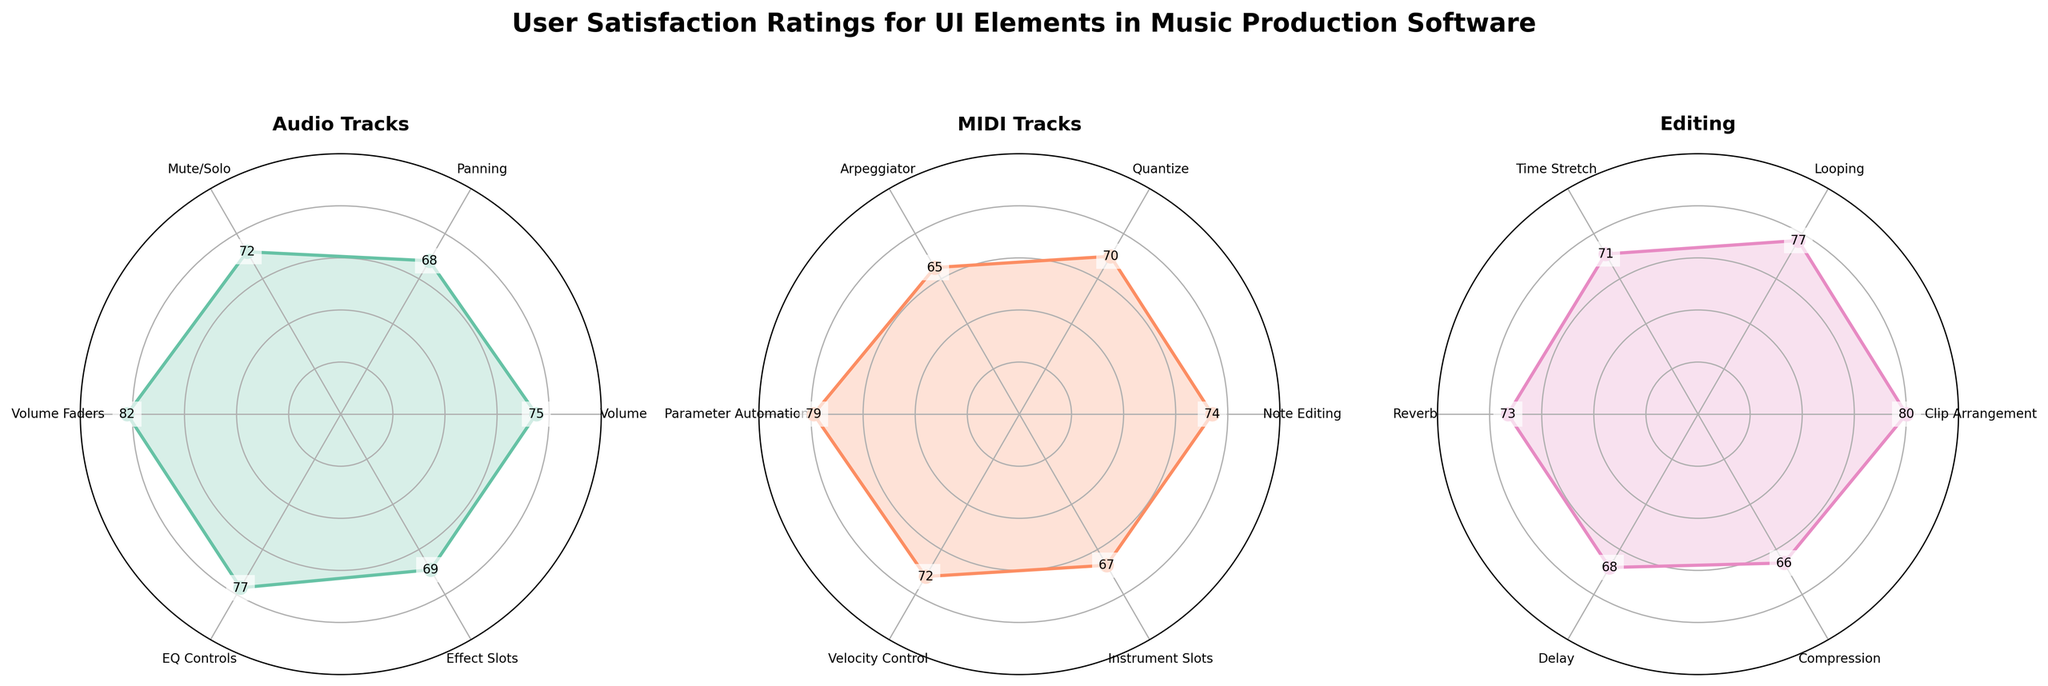How many elements are evaluated under the 'Audio Tracks' category? Count the number of labeled elements under the 'Audio Tracks' category in the chart.
Answer: 6 Which UI element has the highest user satisfaction rating in the 'Editing' category? Look at the values inside the 'Editing' category sub-plot and identify the highest one.
Answer: Clip Arrangement What is the average satisfaction rating for the 'Track Controls' elements of 'MIDI Tracks'? Add the ratings for Note Editing, Quantize, and Arpeggiator, then divide by 3 to find the average.
Answer: (74 + 70 + 65) / 3 = 69.67 How does the satisfaction rating of 'Volume Faders' in 'Audio Tracks' compare to 'Velocity Control' in 'MIDI Tracks'? Compare the values of Volume Faders (82) and Velocity Control (72).
Answer: Volume Faders > Velocity Control Which category has the most balanced satisfaction ratings, i.e., least variation among the elements? Look at how the ratings of elements within each category cluster together closely.
Answer: Editing What is the difference in satisfaction rating between the 'EQ Controls' and 'Effect Slots' in 'Audio Tracks'? Subtract the satisfaction rating of 'Effect Slots' from 'EQ Controls'.
Answer: 77 - 69 = 8 Identify which 'Track Controls' element in 'Audio Tracks' has the lowest rating and specify the value. Find the lowest value among Volume, Panning, and Mute/Solo in the 'Audio Tracks' sub-plot.
Answer: Panning, 68 What is the rating for 'Reverb' in the 'Effects' section of 'Editing'? Read the value paired with 'Reverb' in the Editing sub-plot.
Answer: 73 Are there any elements in the 'MIDI Tracks' category with satisfaction ratings below 70? If so, name them. Identify ratings below 70 in 'MIDI Tracks' and list those elements.
Answer: Arpeggiator (65), Instrument Slots (67) Which elements in the 'Track Controls' of 'Audio Tracks' and 'Mixer' of 'MIDI Tracks' have equal satisfaction ratings? Compare individual ratings of elements in these two sub-plots to find matches.
Answer: Mute/Solo and Velocity Control (72 each) 